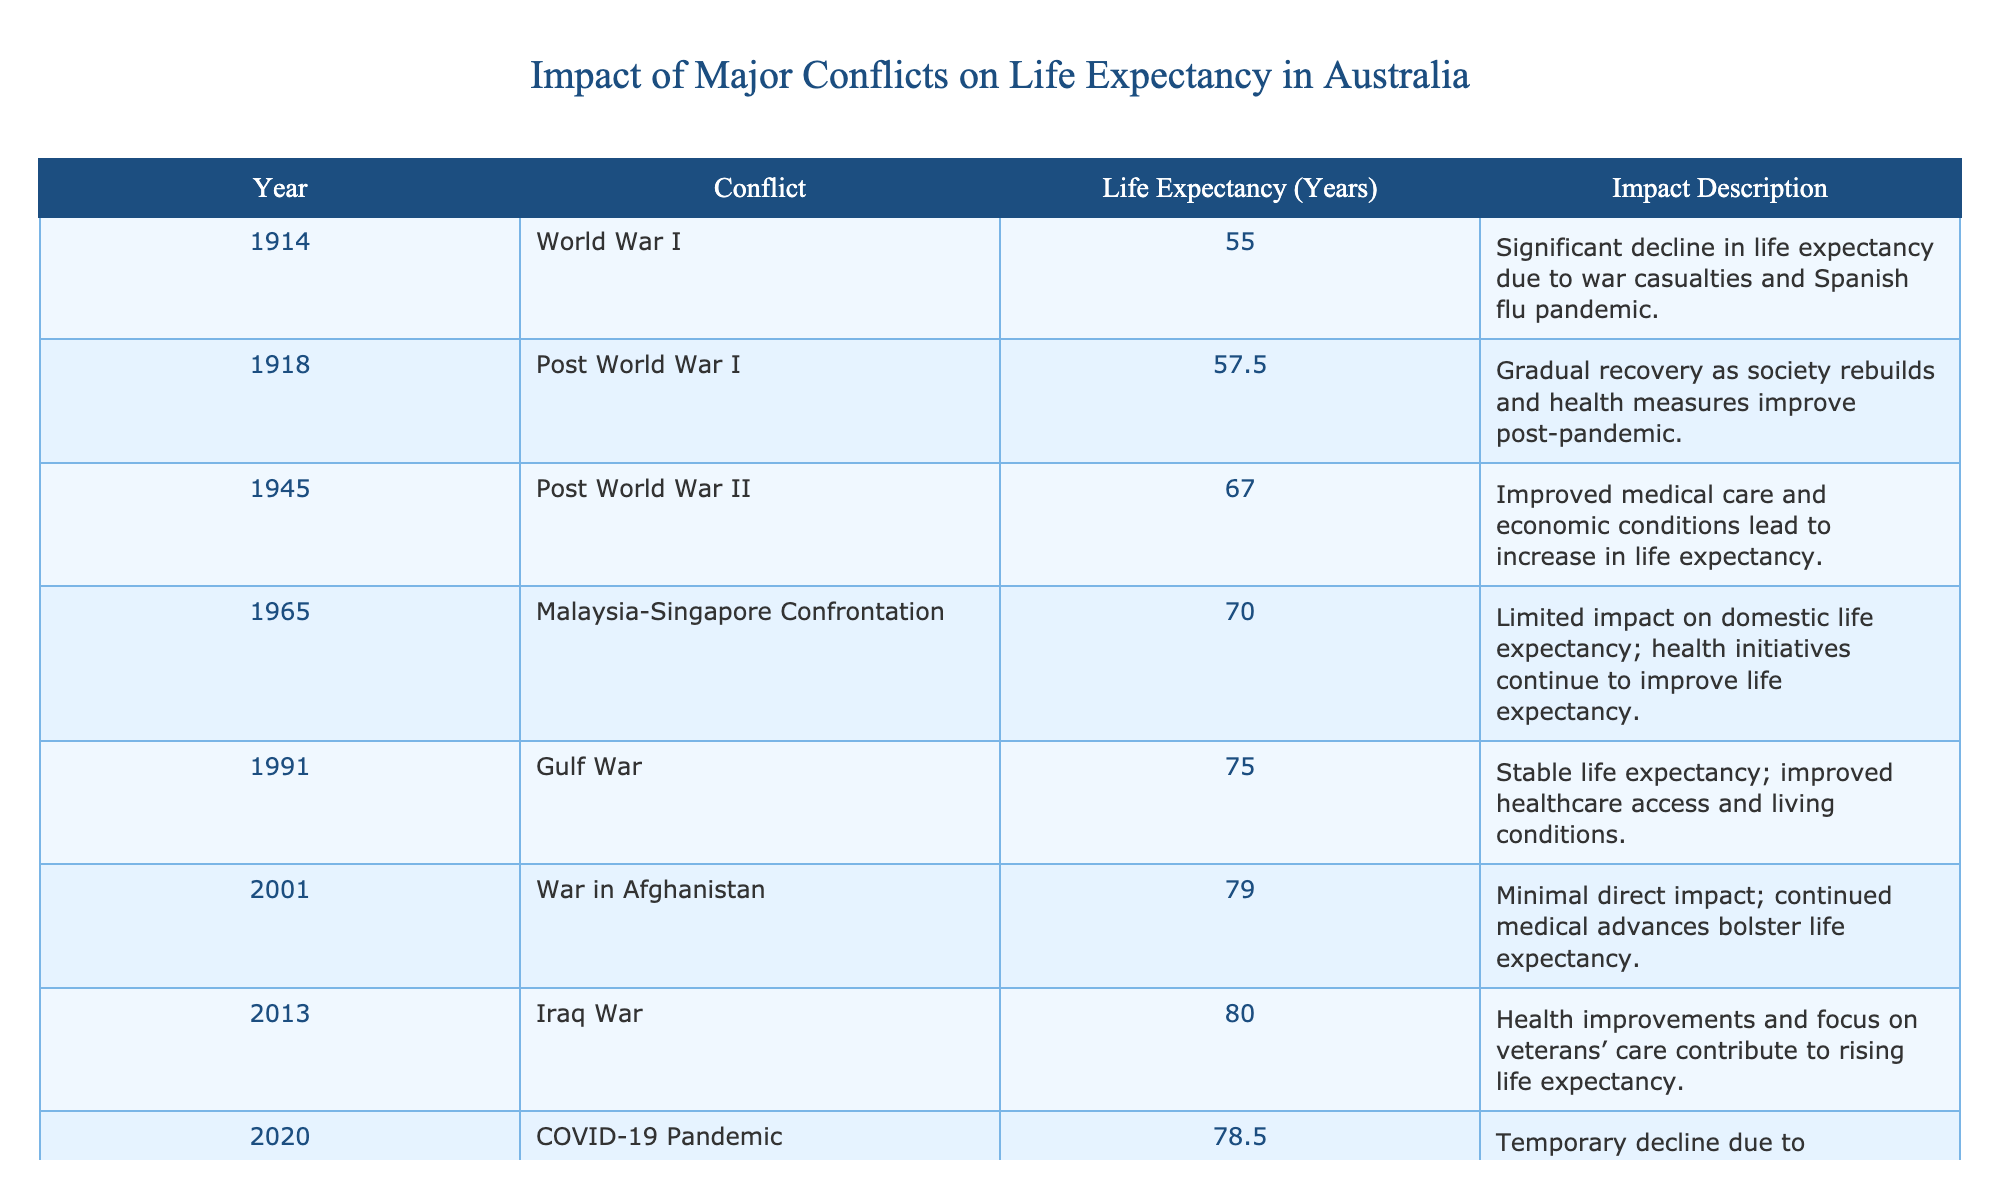What was the life expectancy in Australia in 1945? Referring to the table, the year 1945 corresponds to the Post World War II conflict, which shows a life expectancy of 67.0 years.
Answer: 67.0 years What impact did World War I have on life expectancy? The table indicates that there was a significant decline in life expectancy due to war casualties and the Spanish flu pandemic during World War I, with life expectancy dropping to 55.0 years in 1914.
Answer: Significant decline What were the life expectancy changes from 2001 to 2013? In 2001, the life expectancy was 79.0 years, and by 2013, it rose to 80.0 years. Therefore, the change is an increase of 1.0 years over that period.
Answer: Increased by 1.0 year Is life expectancy higher in the Post-COVID Recovery period compared to the COVID-19 Pandemic? Yes, the life expectancy in the Post-COVID Recovery period is 80.5 years, while during the COVID-19 Pandemic it was 78.5 years, indicating an increase.
Answer: Yes What was the average life expectancy during the conflicts listed in the table? To find the average, sum all life expectancies: 55.0 + 57.5 + 67.0 + 70.0 + 75.0 + 79.0 + 80.0 + 78.5 + 80.5 = 663.5 years. There are 9 entries, so the average is 663.5 / 9 = 73.72 years.
Answer: 73.72 years What were the life expectancy values before and after the Iraq War? Before the Iraq War in 2013, the life expectancy was 80.0 years. After the conflict in 2013, the life expectancy was recorded at 80.5 years in the Post-COVID Recovery. Thus, it increased by 0.5 years.
Answer: Increased by 0.5 years Did the Malaysian-Singaporean Conflict have a significant impact on life expectancy? No, according to the table, the life expectancy remained at 70.0 years, indicating that the impact on domestic life expectancy was limited.
Answer: No What is the difference in life expectancy from 1914 to 2023? The life expectancy in 1914 was 55.0 years, and it increased to 80.5 years in 2023. Therefore, the difference is 80.5 - 55.0 = 25.5 years.
Answer: 25.5 years 